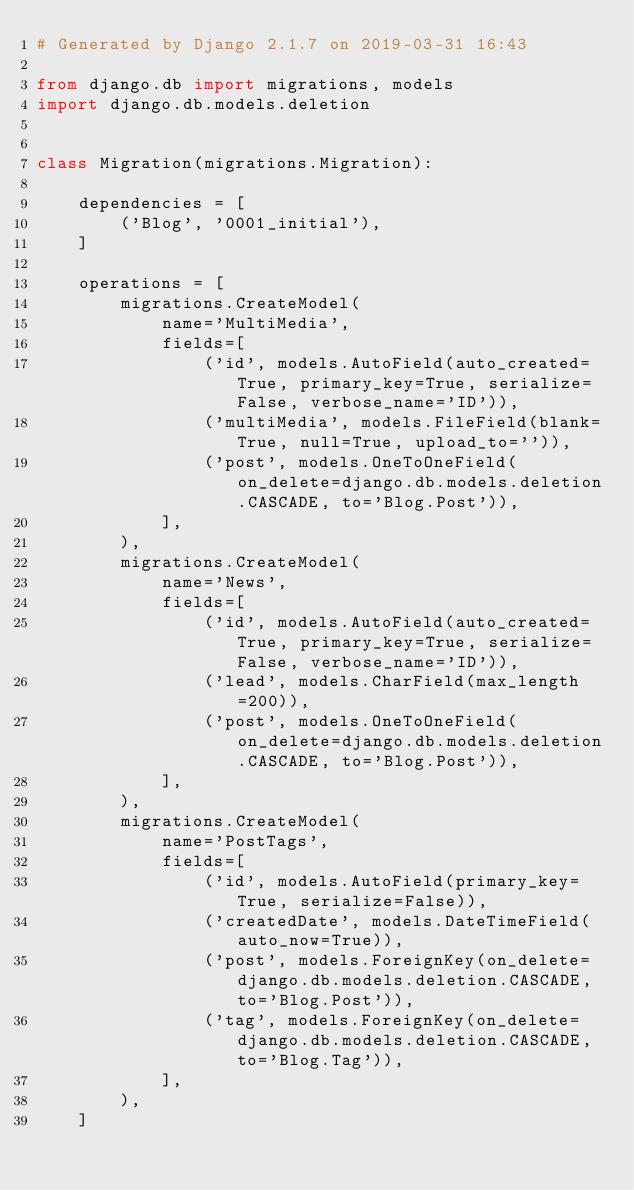Convert code to text. <code><loc_0><loc_0><loc_500><loc_500><_Python_># Generated by Django 2.1.7 on 2019-03-31 16:43

from django.db import migrations, models
import django.db.models.deletion


class Migration(migrations.Migration):

    dependencies = [
        ('Blog', '0001_initial'),
    ]

    operations = [
        migrations.CreateModel(
            name='MultiMedia',
            fields=[
                ('id', models.AutoField(auto_created=True, primary_key=True, serialize=False, verbose_name='ID')),
                ('multiMedia', models.FileField(blank=True, null=True, upload_to='')),
                ('post', models.OneToOneField(on_delete=django.db.models.deletion.CASCADE, to='Blog.Post')),
            ],
        ),
        migrations.CreateModel(
            name='News',
            fields=[
                ('id', models.AutoField(auto_created=True, primary_key=True, serialize=False, verbose_name='ID')),
                ('lead', models.CharField(max_length=200)),
                ('post', models.OneToOneField(on_delete=django.db.models.deletion.CASCADE, to='Blog.Post')),
            ],
        ),
        migrations.CreateModel(
            name='PostTags',
            fields=[
                ('id', models.AutoField(primary_key=True, serialize=False)),
                ('createdDate', models.DateTimeField(auto_now=True)),
                ('post', models.ForeignKey(on_delete=django.db.models.deletion.CASCADE, to='Blog.Post')),
                ('tag', models.ForeignKey(on_delete=django.db.models.deletion.CASCADE, to='Blog.Tag')),
            ],
        ),
    ]
</code> 